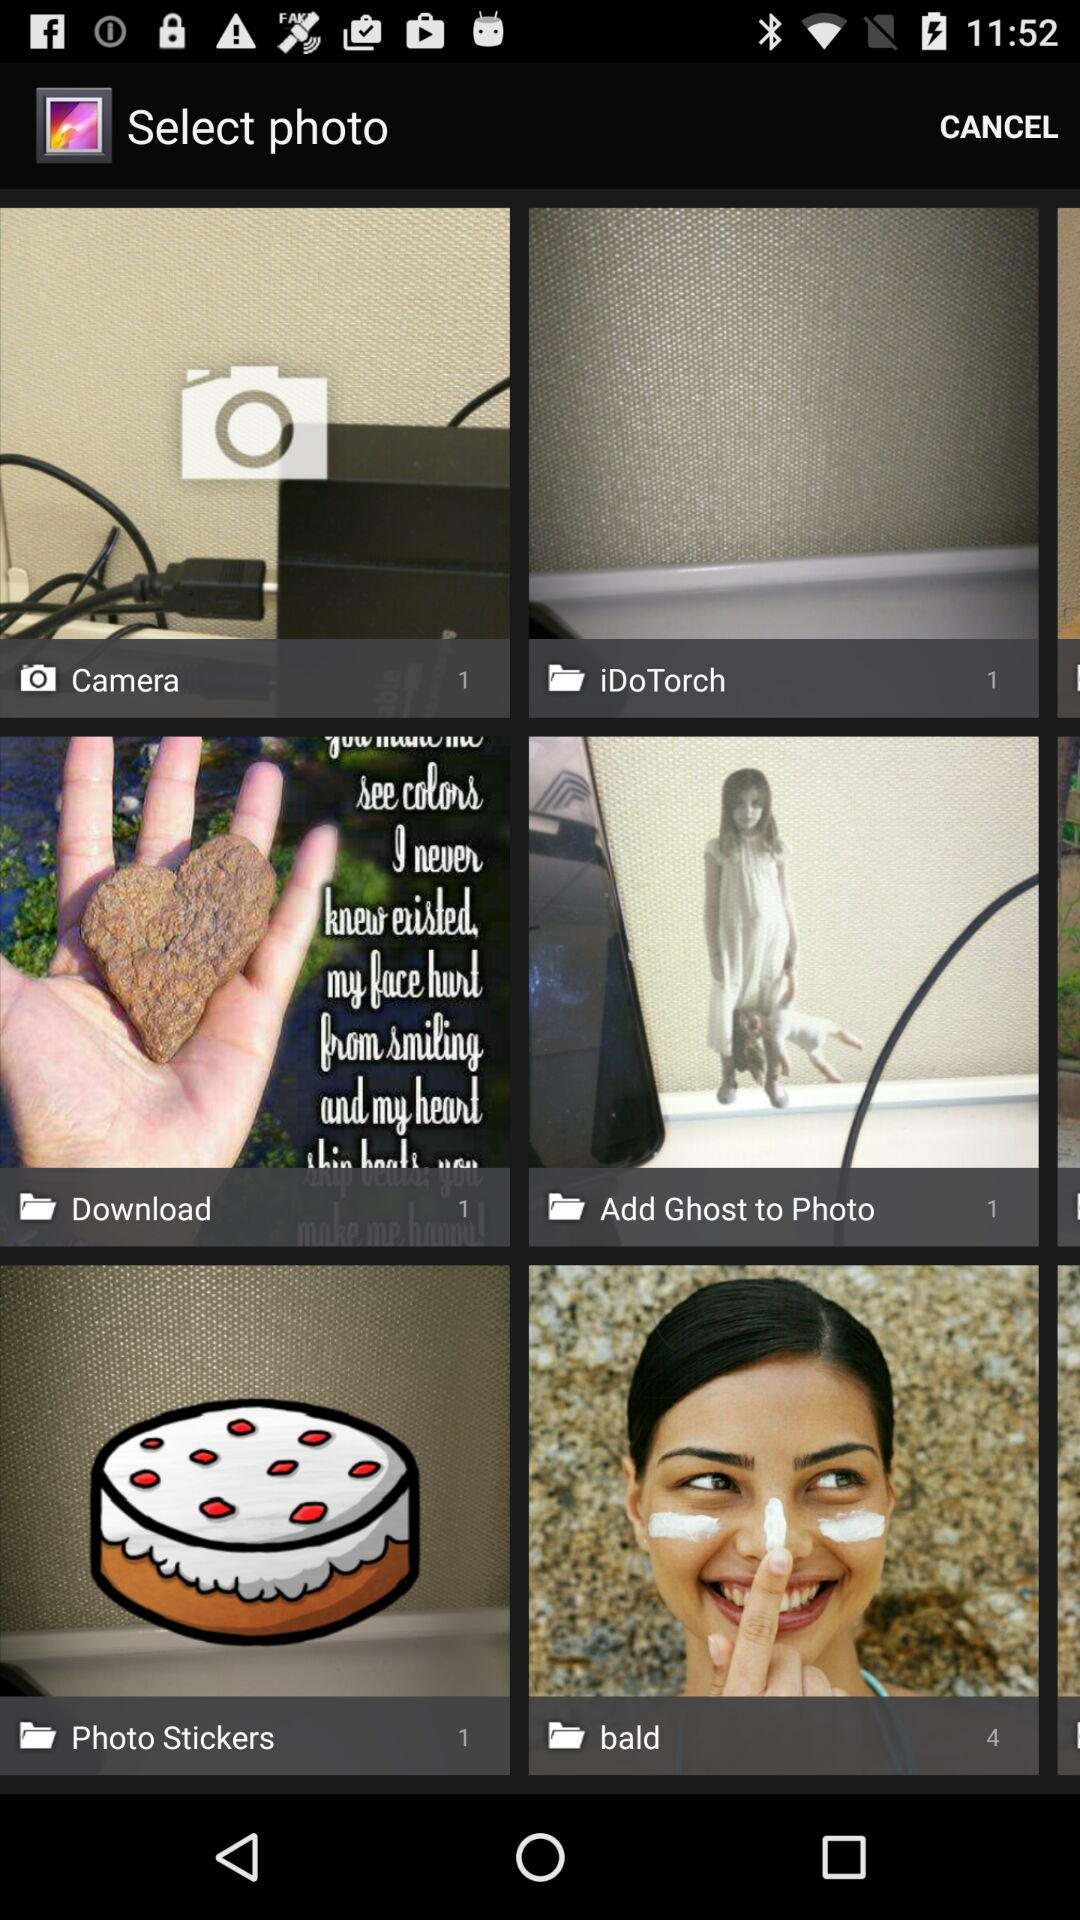What is the number of pictures in the "bald" folder? The number of pictures in the "bald" folder is 4. 